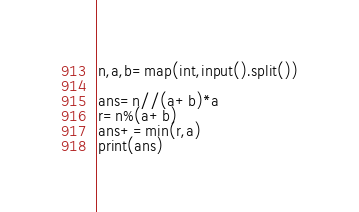<code> <loc_0><loc_0><loc_500><loc_500><_Python_>n,a,b=map(int,input().split())
 
ans=n//(a+b)*a
r=n%(a+b)
ans+=min(r,a)
print(ans)</code> 